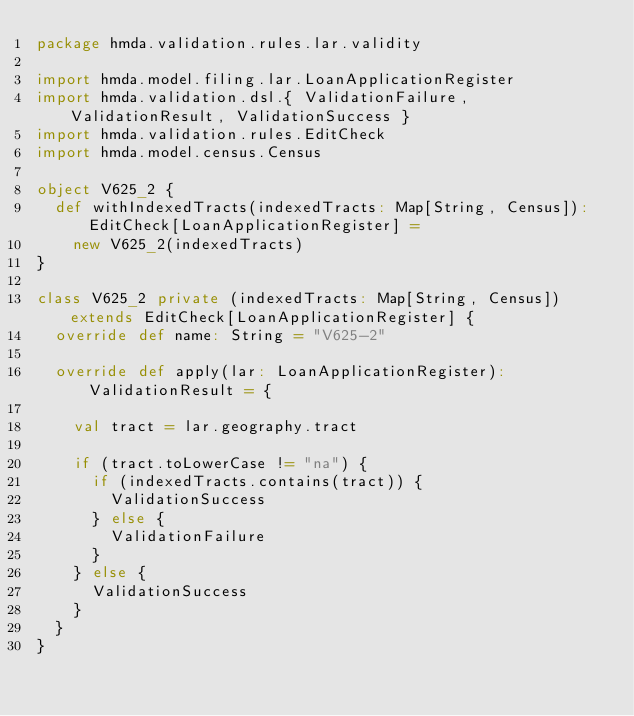Convert code to text. <code><loc_0><loc_0><loc_500><loc_500><_Scala_>package hmda.validation.rules.lar.validity

import hmda.model.filing.lar.LoanApplicationRegister
import hmda.validation.dsl.{ ValidationFailure, ValidationResult, ValidationSuccess }
import hmda.validation.rules.EditCheck
import hmda.model.census.Census

object V625_2 {
  def withIndexedTracts(indexedTracts: Map[String, Census]): EditCheck[LoanApplicationRegister] =
    new V625_2(indexedTracts)
}

class V625_2 private (indexedTracts: Map[String, Census]) extends EditCheck[LoanApplicationRegister] {
  override def name: String = "V625-2"

  override def apply(lar: LoanApplicationRegister): ValidationResult = {

    val tract = lar.geography.tract

    if (tract.toLowerCase != "na") {
      if (indexedTracts.contains(tract)) {
        ValidationSuccess
      } else {
        ValidationFailure
      }
    } else {
      ValidationSuccess
    }
  }
}
</code> 